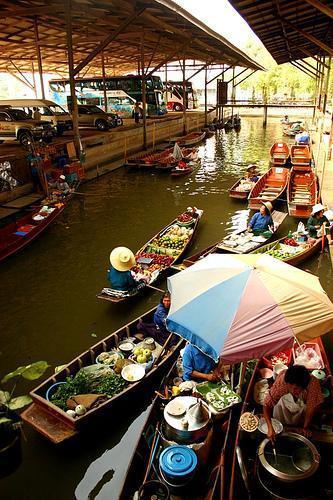How many busses are shown in this picture?
Give a very brief answer. 2. How many boats can you see?
Give a very brief answer. 5. How many benches are depicted?
Give a very brief answer. 0. 